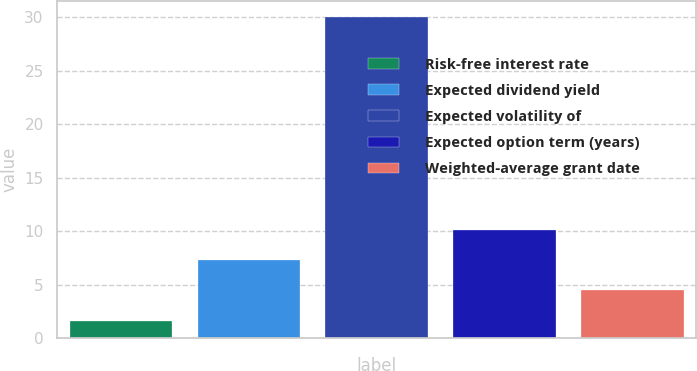Convert chart to OTSL. <chart><loc_0><loc_0><loc_500><loc_500><bar_chart><fcel>Risk-free interest rate<fcel>Expected dividend yield<fcel>Expected volatility of<fcel>Expected option term (years)<fcel>Weighted-average grant date<nl><fcel>1.63<fcel>7.31<fcel>30<fcel>10.15<fcel>4.47<nl></chart> 